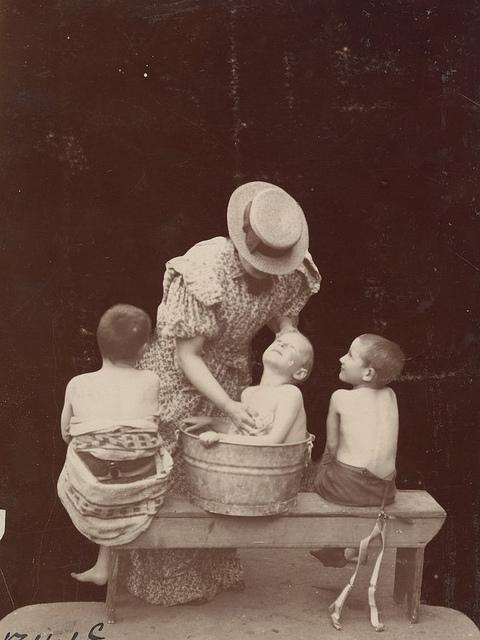How many children are in this photo?
Give a very brief answer. 3. How many people can be seen?
Give a very brief answer. 4. How many people are wearing an orange tee shirt?
Give a very brief answer. 0. 